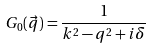Convert formula to latex. <formula><loc_0><loc_0><loc_500><loc_500>G _ { 0 } ( \vec { q } ) = \frac { 1 } { k ^ { 2 } - q ^ { 2 } + i \delta }</formula> 